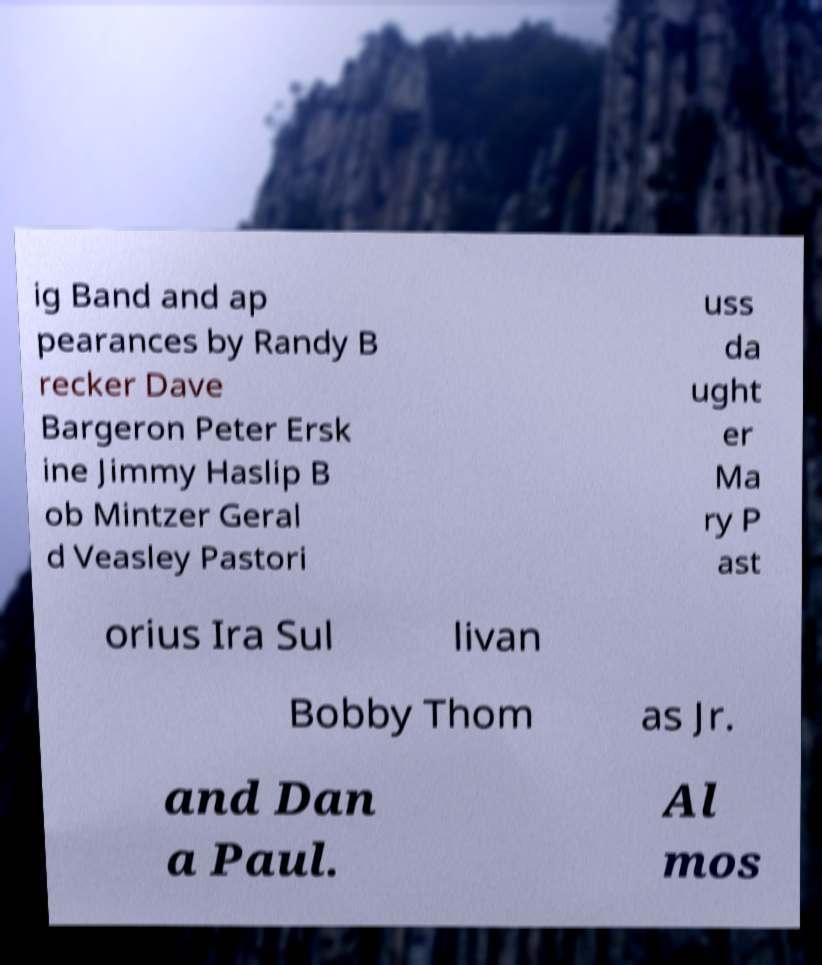Please read and relay the text visible in this image. What does it say? ig Band and ap pearances by Randy B recker Dave Bargeron Peter Ersk ine Jimmy Haslip B ob Mintzer Geral d Veasley Pastori uss da ught er Ma ry P ast orius Ira Sul livan Bobby Thom as Jr. and Dan a Paul. Al mos 